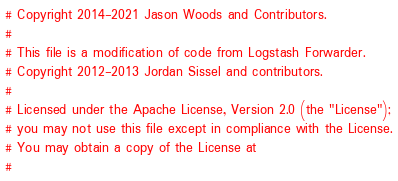<code> <loc_0><loc_0><loc_500><loc_500><_Ruby_># Copyright 2014-2021 Jason Woods and Contributors.
#
# This file is a modification of code from Logstash Forwarder.
# Copyright 2012-2013 Jordan Sissel and contributors.
#
# Licensed under the Apache License, Version 2.0 (the "License");
# you may not use this file except in compliance with the License.
# You may obtain a copy of the License at
#</code> 